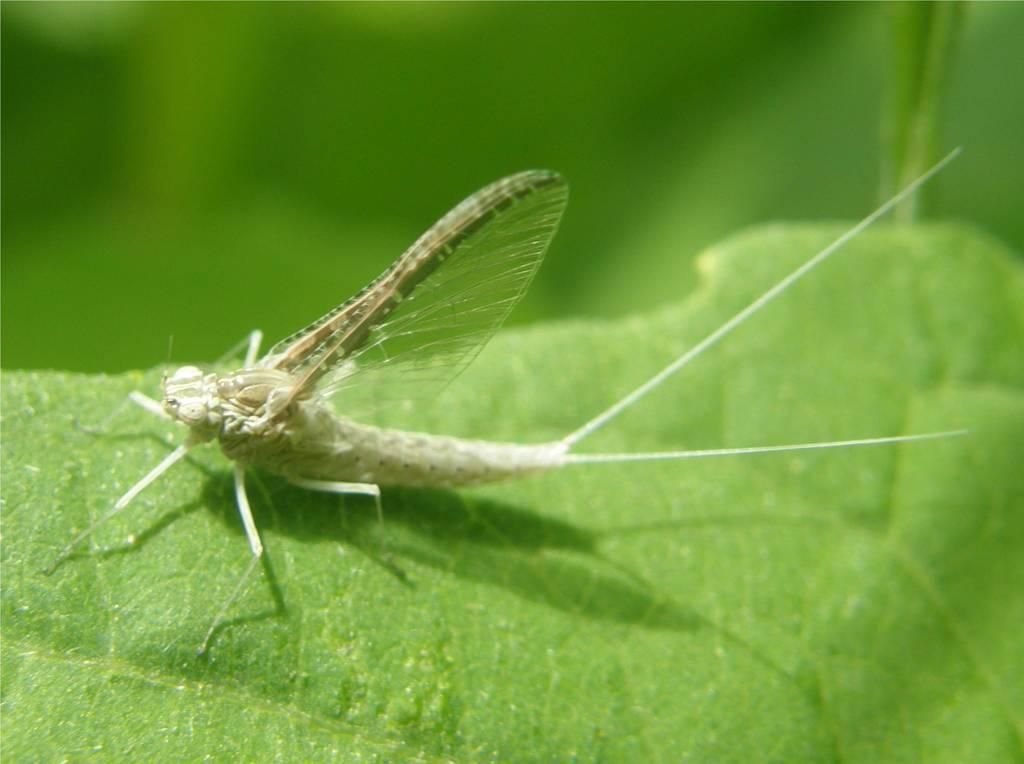What is present on the leaf in the image? There is an insect on the leaf in the image. Can you describe the insect's location on the leaf? The insect is on the leaf in the image. What type of oatmeal is the insect eating in the image? There is no oatmeal present in the image; the insect is on a leaf. How does the insect show respect to the leaf in the image? The concept of respect does not apply to insects and leaves in this context, as they are inanimate objects and do not have the ability to show respect. 